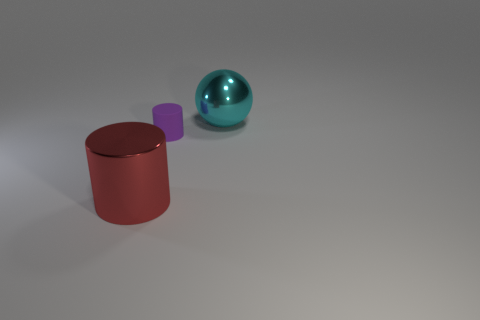Add 2 tiny cyan metallic things. How many objects exist? 5 Add 1 red metallic cylinders. How many red metallic cylinders are left? 2 Add 1 tiny spheres. How many tiny spheres exist? 1 Subtract 0 green spheres. How many objects are left? 3 Subtract all spheres. How many objects are left? 2 Subtract 1 spheres. How many spheres are left? 0 Subtract all brown balls. Subtract all green cylinders. How many balls are left? 1 Subtract all yellow cylinders. How many gray spheres are left? 0 Subtract all purple rubber objects. Subtract all purple objects. How many objects are left? 1 